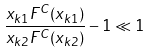Convert formula to latex. <formula><loc_0><loc_0><loc_500><loc_500>\frac { x _ { k 1 } F ^ { C } ( x _ { k 1 } ) } { x _ { k 2 } F ^ { C } ( x _ { k 2 } ) } - 1 \ll 1</formula> 